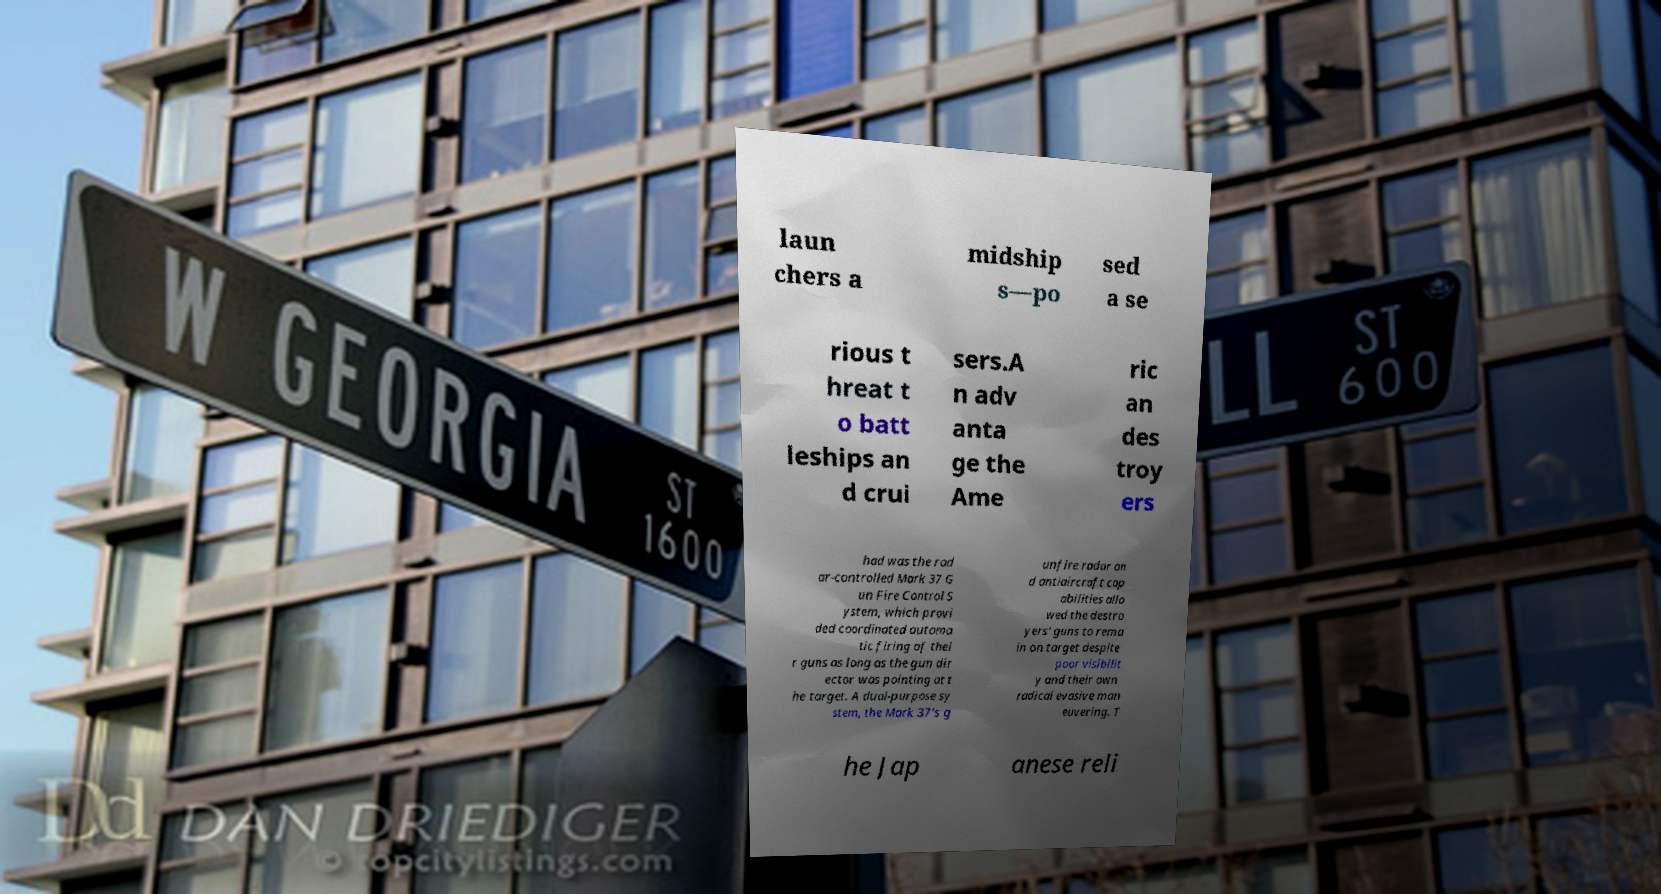Can you accurately transcribe the text from the provided image for me? laun chers a midship s—po sed a se rious t hreat t o batt leships an d crui sers.A n adv anta ge the Ame ric an des troy ers had was the rad ar-controlled Mark 37 G un Fire Control S ystem, which provi ded coordinated automa tic firing of thei r guns as long as the gun dir ector was pointing at t he target. A dual-purpose sy stem, the Mark 37's g unfire radar an d antiaircraft cap abilities allo wed the destro yers' guns to rema in on target despite poor visibilit y and their own radical evasive man euvering. T he Jap anese reli 